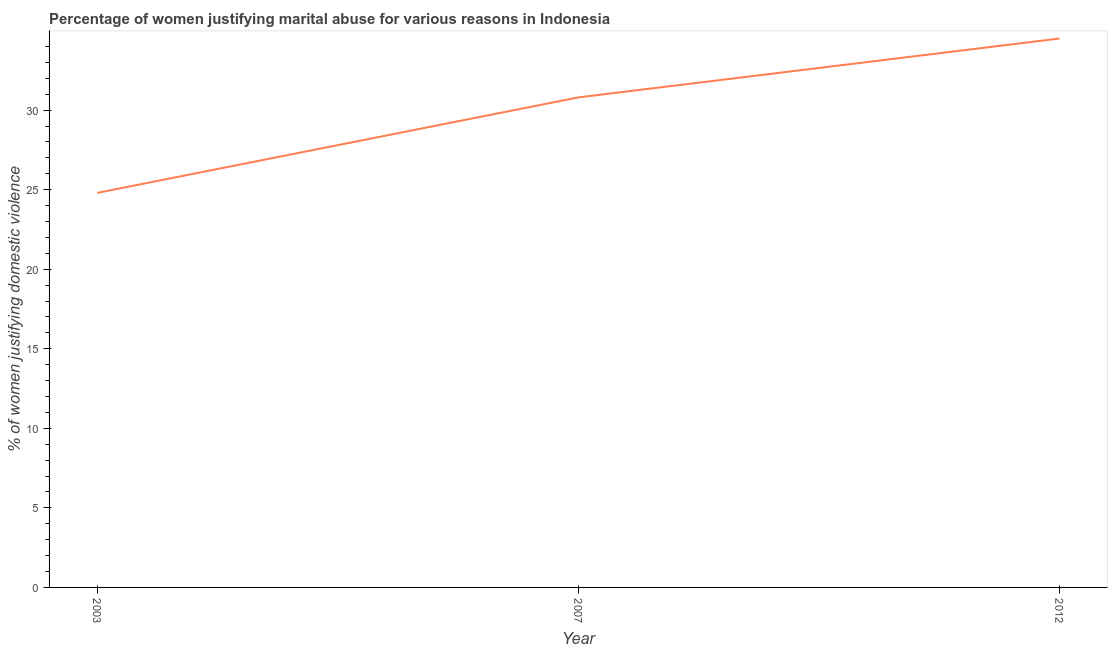What is the percentage of women justifying marital abuse in 2007?
Make the answer very short. 30.8. Across all years, what is the maximum percentage of women justifying marital abuse?
Provide a short and direct response. 34.5. Across all years, what is the minimum percentage of women justifying marital abuse?
Offer a very short reply. 24.8. In which year was the percentage of women justifying marital abuse maximum?
Give a very brief answer. 2012. What is the sum of the percentage of women justifying marital abuse?
Make the answer very short. 90.1. What is the average percentage of women justifying marital abuse per year?
Your answer should be compact. 30.03. What is the median percentage of women justifying marital abuse?
Ensure brevity in your answer.  30.8. In how many years, is the percentage of women justifying marital abuse greater than 12 %?
Your answer should be compact. 3. Do a majority of the years between 2003 and 2012 (inclusive) have percentage of women justifying marital abuse greater than 27 %?
Give a very brief answer. Yes. What is the ratio of the percentage of women justifying marital abuse in 2003 to that in 2007?
Your answer should be very brief. 0.81. Is the percentage of women justifying marital abuse in 2003 less than that in 2012?
Keep it short and to the point. Yes. Is the difference between the percentage of women justifying marital abuse in 2003 and 2012 greater than the difference between any two years?
Keep it short and to the point. Yes. What is the difference between the highest and the second highest percentage of women justifying marital abuse?
Provide a short and direct response. 3.7. Does the graph contain any zero values?
Keep it short and to the point. No. Does the graph contain grids?
Your response must be concise. No. What is the title of the graph?
Keep it short and to the point. Percentage of women justifying marital abuse for various reasons in Indonesia. What is the label or title of the X-axis?
Keep it short and to the point. Year. What is the label or title of the Y-axis?
Provide a succinct answer. % of women justifying domestic violence. What is the % of women justifying domestic violence of 2003?
Your answer should be compact. 24.8. What is the % of women justifying domestic violence of 2007?
Keep it short and to the point. 30.8. What is the % of women justifying domestic violence in 2012?
Your response must be concise. 34.5. What is the difference between the % of women justifying domestic violence in 2007 and 2012?
Keep it short and to the point. -3.7. What is the ratio of the % of women justifying domestic violence in 2003 to that in 2007?
Provide a succinct answer. 0.81. What is the ratio of the % of women justifying domestic violence in 2003 to that in 2012?
Your answer should be very brief. 0.72. What is the ratio of the % of women justifying domestic violence in 2007 to that in 2012?
Provide a succinct answer. 0.89. 